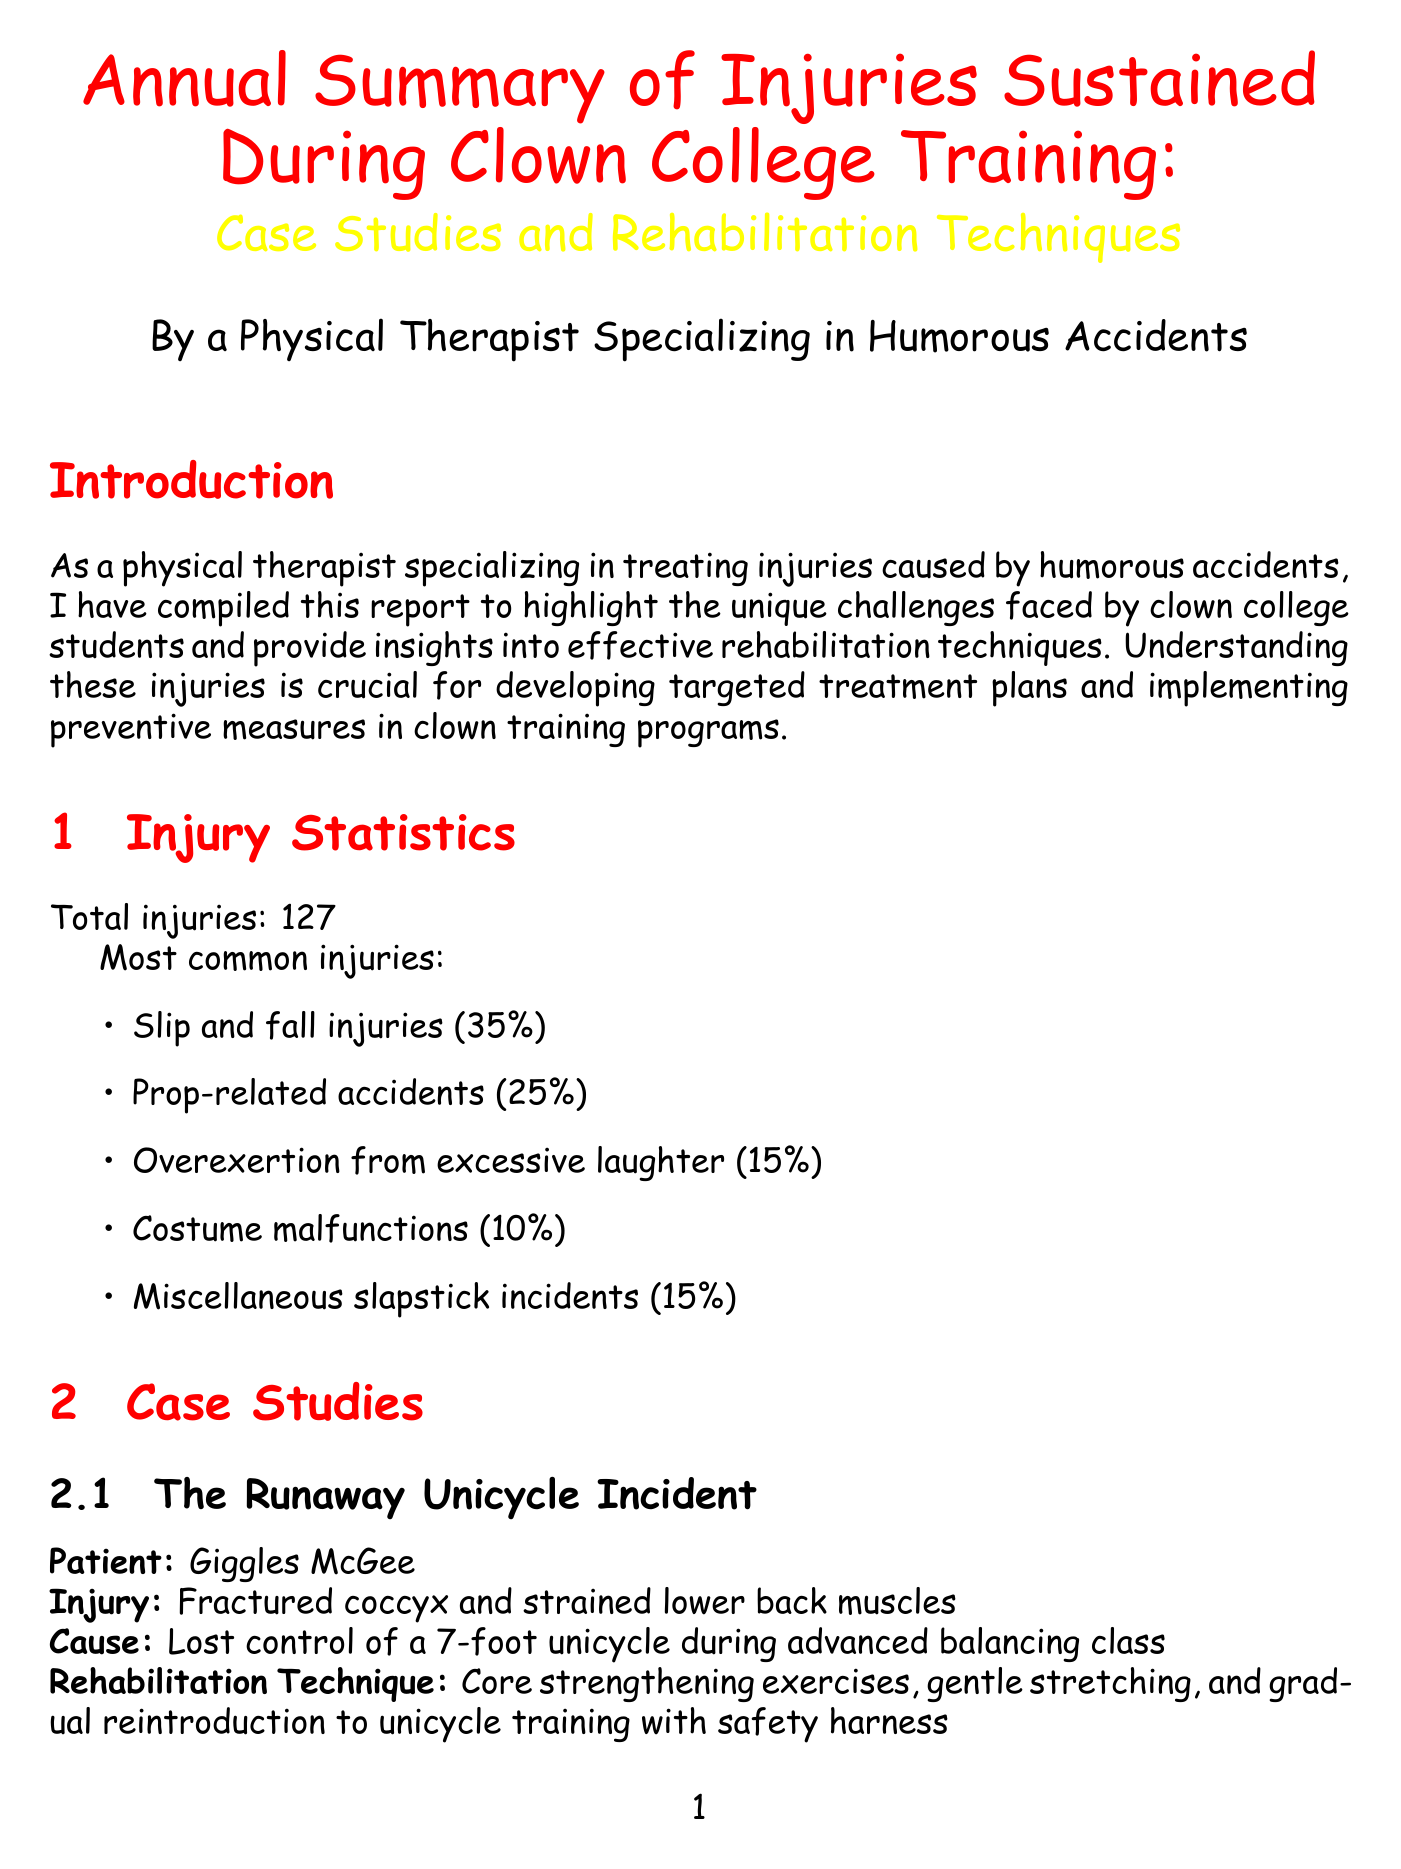What is the title of the report? The title of the report is explicitly mentioned at the beginning of the document.
Answer: Annual Summary of Injuries Sustained During Clown College Training: Case Studies and Rehabilitation Techniques How many total injuries were recorded? The document specifies the total number of injuries recorded in the injury statistics section.
Answer: 127 What percentage of injuries are due to slip and fall incidents? The document provides the distribution of various types of injuries, including the percentage of slip and fall injuries.
Answer: 35% Who is the patient involved in "The Banana Peel Slip-Up"? The case study details include the name of the patient for this specific incident.
Answer: Buster Keaton Jr What rehabilitation technique involves using circus-inspired exercises? The document describes various rehabilitation techniques and identifies the one related to circus exercises.
Answer: Circus-Inspired Functional Training Which injury caused Giggles McGee? The case study associated with Giggles McGee specifies the injury linked to the incident.
Answer: Fractured coccyx and strained lower back muscles What is one preventive measure suggested in the document? The document lists several preventive measures aimed at reducing injuries during training.
Answer: Implementing comprehensive warm-up routines before performances and training sessions What is the benefit of Laughter Yoga mentioned? The rehabilitation techniques outline various benefits of specific exercises, including Laughter Yoga.
Answer: Increases endorphin production 